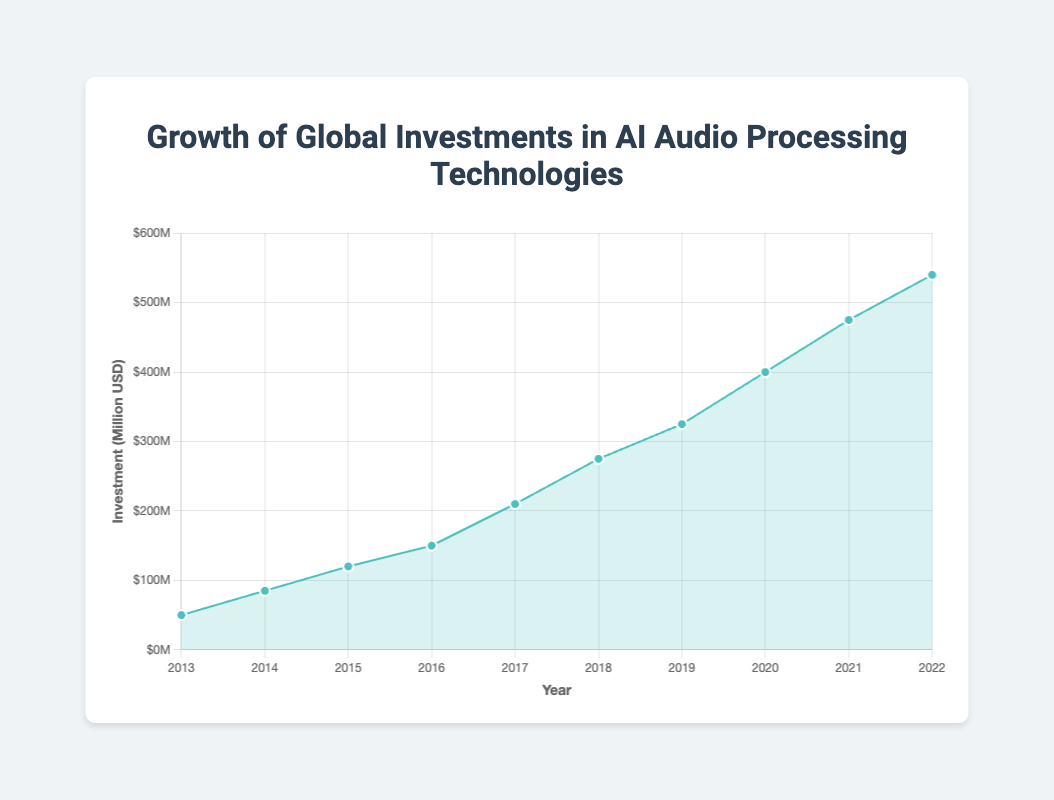What's the highest investment recorded in the data? By examining the data points, you can see that the highest investment recorded is in the year 2022 with $540 million.
Answer: $540 million What is the trend of investments from 2013 to 2022? The trend shows a continuous increase in investments from 2013 to 2022, with no year showing a decrease.
Answer: Increasing What year saw the highest increase in investment compared to the previous year? Calculate the differences between each consecutive year's investment. The highest difference is between 2019 and 2020, where investment increased by $75 million ($400M - $325M).
Answer: 2020 Which companies were notable in 2015? Refer to the data for the year 2015 which lists the notable companies as Apple and Nuance Communications.
Answer: Apple, Nuance Communications What notable projects were undertaken in 2017? For the year 2017, the notable projects listed are Google Duplex and Tencent AI Lab Voice Processing.
Answer: Google Duplex, Tencent AI Lab Voice Processing What's the average investment over the decade? Sum all investments from 2013 to 2022 and divide by the number of years: (50 + 85 + 120 + 150 + 210 + 275 + 325 + 400 + 475 + 540) / 10 = 2630 / 10 = 263 million dollars.
Answer: $263 million In which year did the investment first exceed $200 million? The investment first exceeded $200 million in the year 2017, where it reached $210 million.
Answer: 2017 How much did the investment grow from 2013 to 2022? Subtract the investment in 2013 from the investment in 2022: $540 million - $50 million = $490 million.
Answer: $490 million Which company appeared most frequently among notable companies? Google appears in 2013, 2017, 2019, and 2022. This is more frequent than any other company.
Answer: Google What's the median investment value over the decade? List the investment values in increasing order: 50, 85, 120, 150, 210, 275, 325, 400, 475, 540. The median is the average of the 5th and 6th values, (210 + 275) / 2 = 242.5 million dollars.
Answer: $242.5 million 